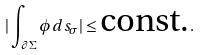Convert formula to latex. <formula><loc_0><loc_0><loc_500><loc_500>| \int _ { \partial \Sigma } \phi d s _ { \sigma } | \leq \text {const.} .</formula> 